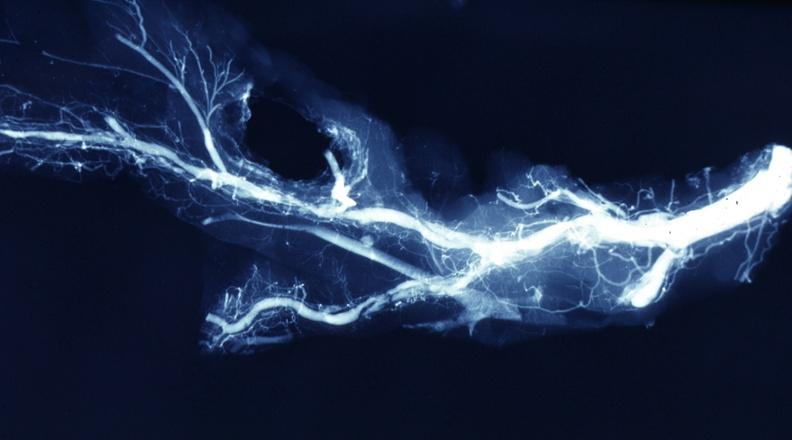what is present?
Answer the question using a single word or phrase. Coronary artery 